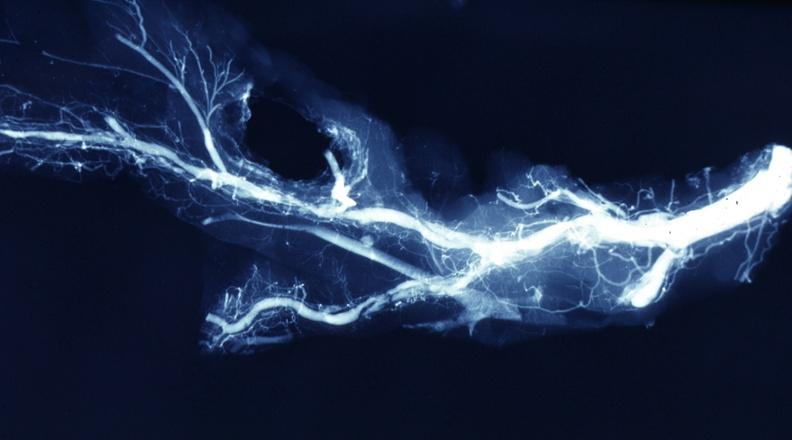what is present?
Answer the question using a single word or phrase. Coronary artery 